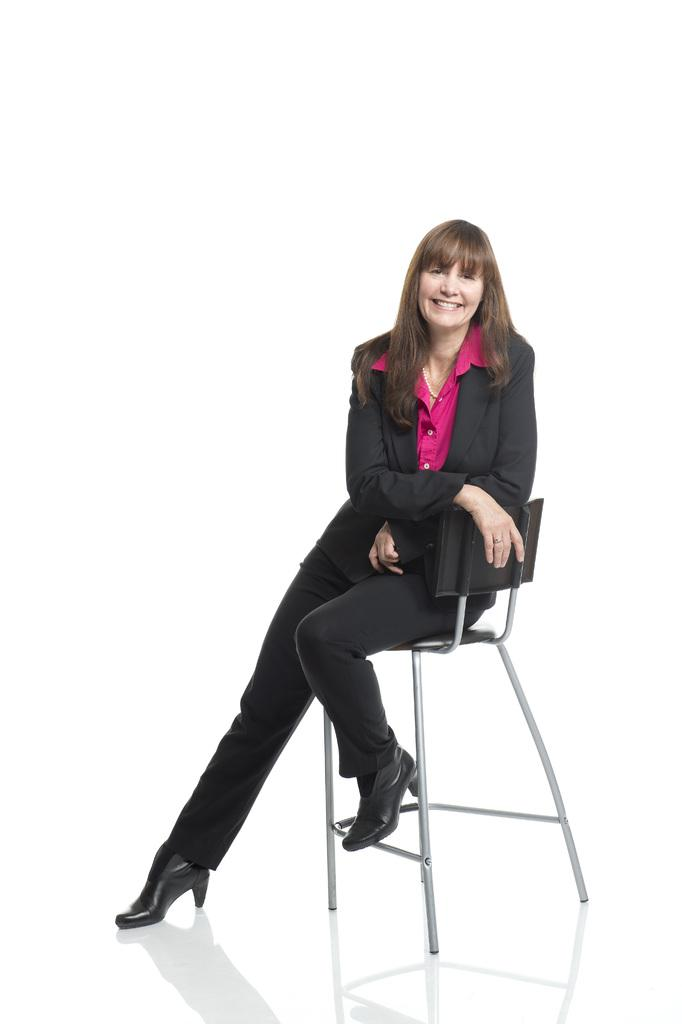Who is the main subject in the image? There is a woman in the image. What is the woman doing in the image? The woman is sitting on a chair and smiling. What can be seen in the background of the image? The background of the image is white. What type of pies is the woman holding in the image? There are no pies present in the image; the woman is sitting on a chair and smiling. 